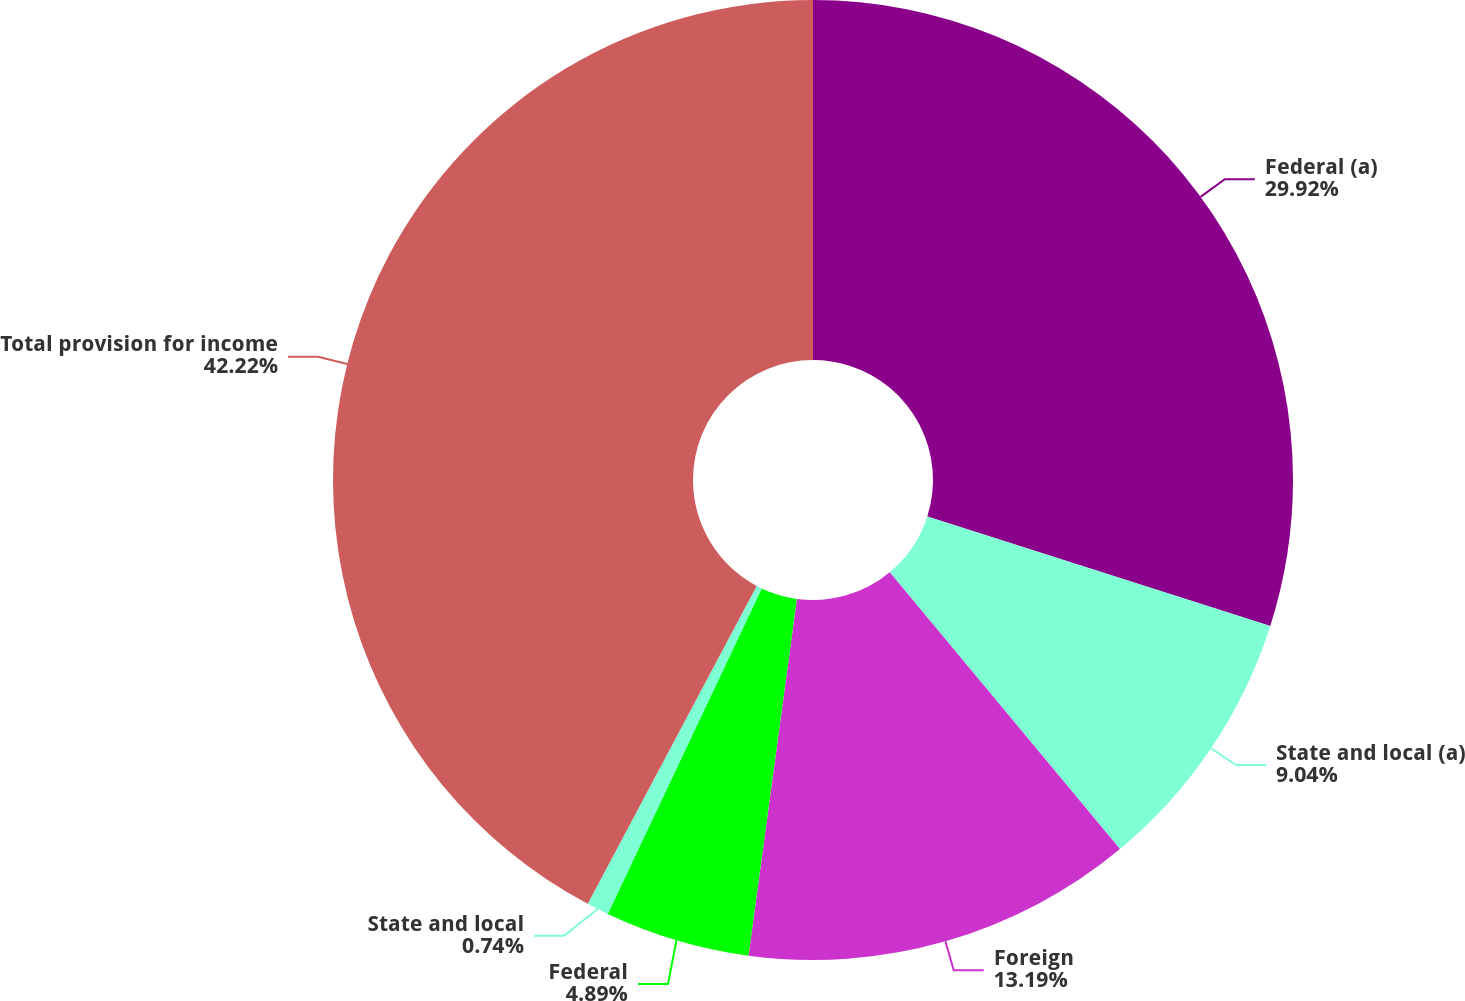<chart> <loc_0><loc_0><loc_500><loc_500><pie_chart><fcel>Federal (a)<fcel>State and local (a)<fcel>Foreign<fcel>Federal<fcel>State and local<fcel>Total provision for income<nl><fcel>29.92%<fcel>9.04%<fcel>13.19%<fcel>4.89%<fcel>0.74%<fcel>42.23%<nl></chart> 